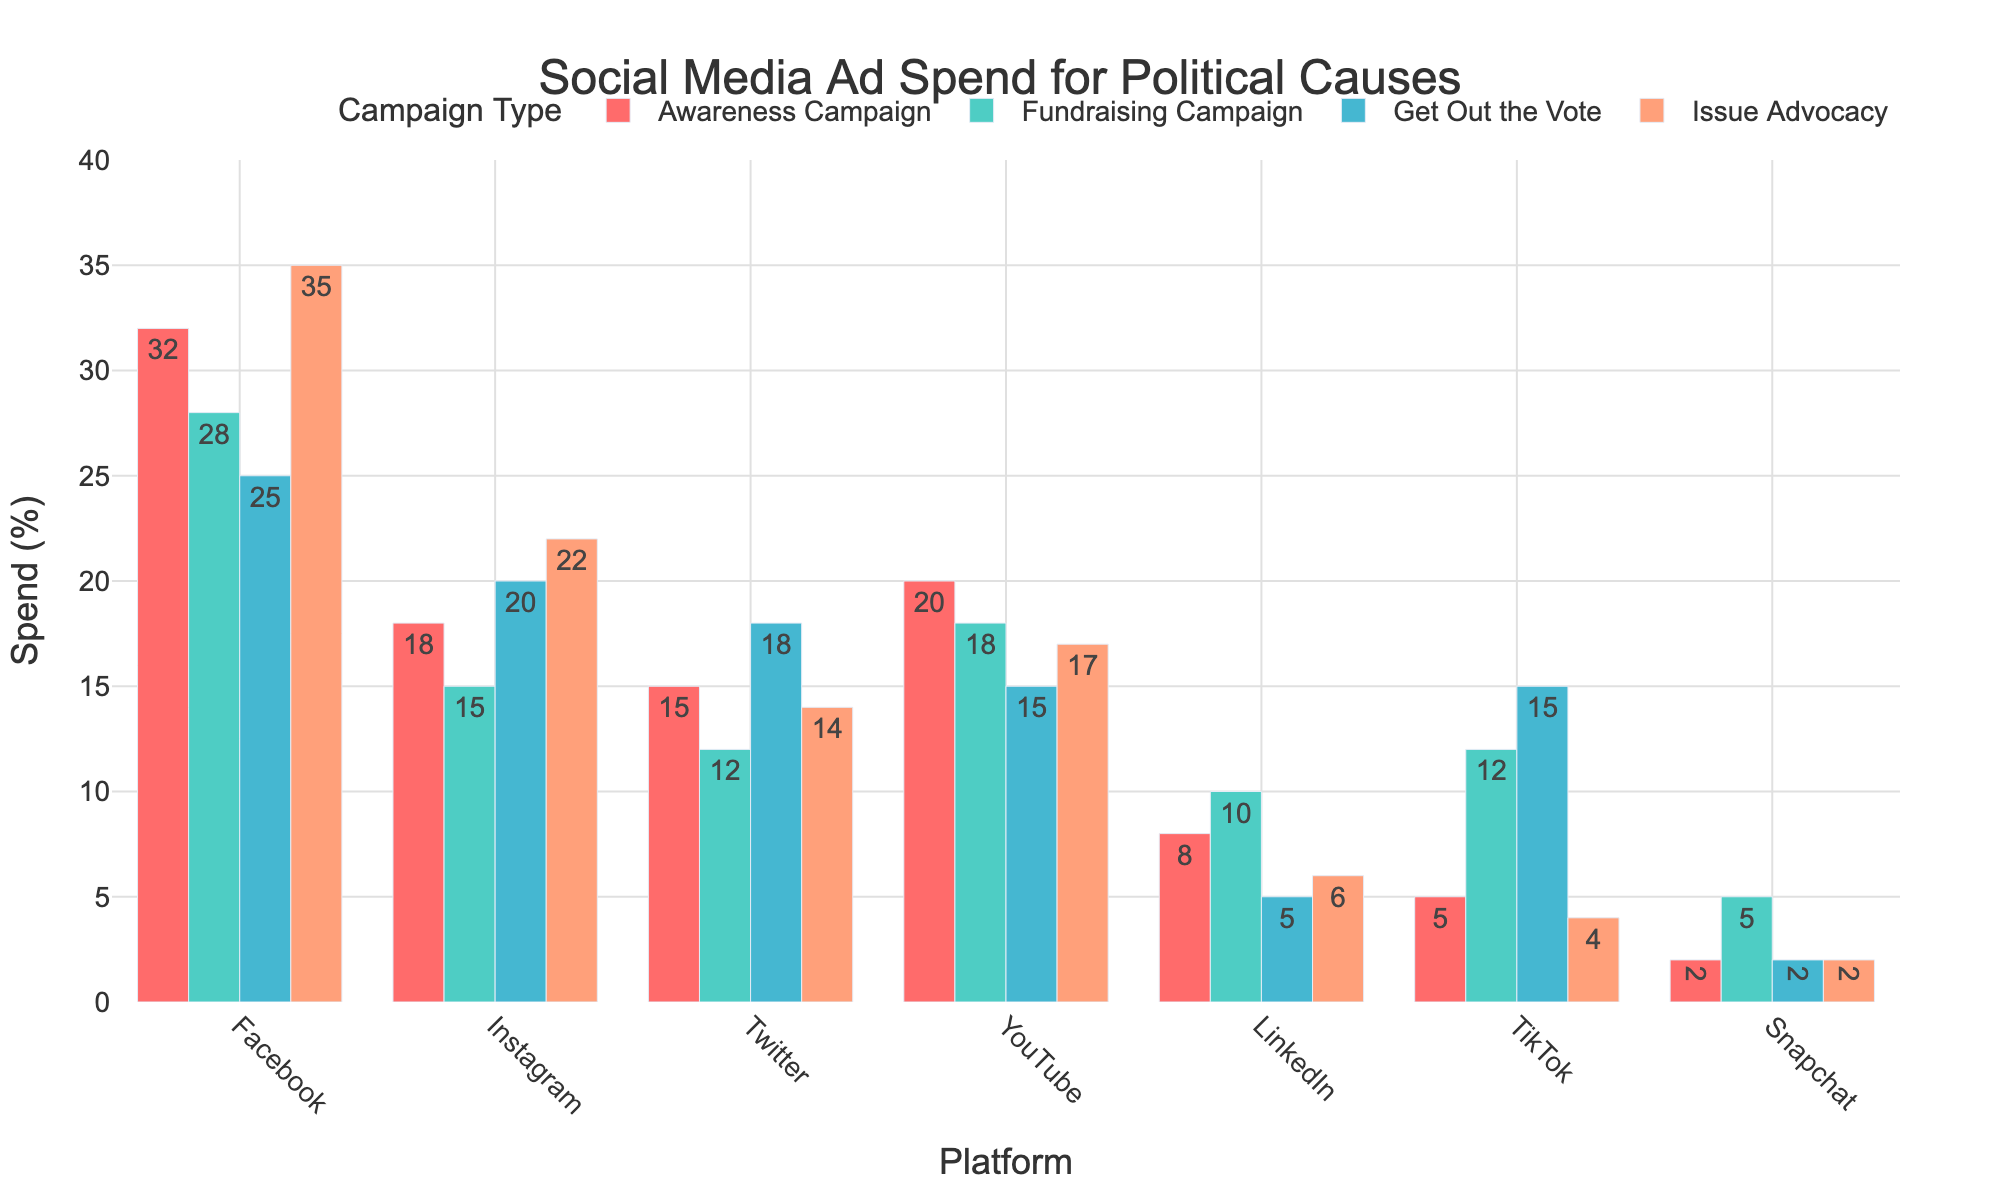Which platform has the highest ad spend for Awareness Campaigns? By observing the heights of the bars for Awareness Campaigns across all platforms, Facebook has the highest ad spend as it reaches the highest point
Answer: Facebook Which campaign type has the lowest ad spend on Snapchat? Looking at the bars for Snapchat, the Issue Advocacy campaign has the shortest bar, indicating the lowest spend
Answer: Issue Advocacy What is the total ad spend on LinkedIn across all campaign types? Adding the heights of the bars for LinkedIn across all campaign types, we find 8 (Awareness Campaign) + 10 (Fundraising Campaign) + 5 (Get Out the Vote) + 6 (Issue Advocacy) = 29
Answer: 29 How much more is spent on Awareness Campaigns on Facebook compared to Twitter? The bar for Awareness Campaigns on Facebook is at 32, while on Twitter it's at 15. The difference is 32 - 15 = 17
Answer: 17 Which platform has the highest ad spend on Get Out the Vote campaigns? Observing the heights of the bars for Get Out the Vote campaigns across platforms, Instagram has the highest ad spend
Answer: Instagram On which platform is the ad spend for Fundraising Campaigns highest and how much is it? By evaluating the bars for Fundraising Campaigns, Facebook has the highest ad spend for these campaigns with a bar height of 28
Answer: Facebook, 28 Is more money spent on Issue Advocacy or Get Out the Vote campaigns across all platforms? Summing the spends for each campaign type across platforms: 
- Issue Advocacy: 35 + 22 + 14 + 17 + 6 + 4 + 2 = 100
- Get Out the Vote: 25 + 20 + 18 + 15 + 5 + 15 + 2 = 100
Both are equal at 100
Answer: Equal at 100 Which campaign type has the smallest variance in ad spend across the platforms? By comparing the range of heights of the bars for each campaign type, Get Out the Vote spends are more uniformly distributed with smaller differences among the platforms
Answer: Get Out the Vote By how much does the total ad spend on TikTok differ from the total ad spend on Instagram? Summing up the spends for TikTok and Instagram across all campaign types:
- TikTok: 5 + 12 + 15 + 4 = 36
- Instagram: 18 + 15 + 20 + 22 = 75
The difference is 75 - 36 = 39
Answer: 39 